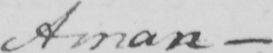Please provide the text content of this handwritten line. Aman 